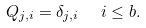<formula> <loc_0><loc_0><loc_500><loc_500>Q _ { j , i } = \delta _ { j , i } \ \ i \leq b .</formula> 